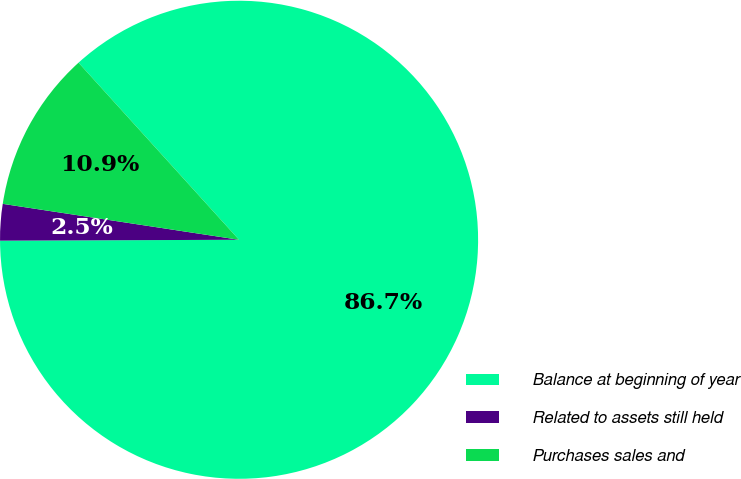<chart> <loc_0><loc_0><loc_500><loc_500><pie_chart><fcel>Balance at beginning of year<fcel>Related to assets still held<fcel>Purchases sales and<nl><fcel>86.66%<fcel>2.46%<fcel>10.88%<nl></chart> 